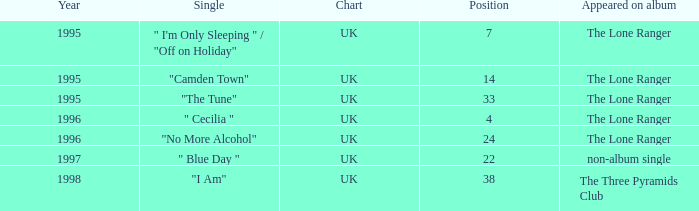What's the typical position after the year 1996? 30.0. Parse the table in full. {'header': ['Year', 'Single', 'Chart', 'Position', 'Appeared on album'], 'rows': [['1995', '" I\'m Only Sleeping " / "Off on Holiday"', 'UK', '7', 'The Lone Ranger'], ['1995', '"Camden Town"', 'UK', '14', 'The Lone Ranger'], ['1995', '"The Tune"', 'UK', '33', 'The Lone Ranger'], ['1996', '" Cecilia "', 'UK', '4', 'The Lone Ranger'], ['1996', '"No More Alcohol"', 'UK', '24', 'The Lone Ranger'], ['1997', '" Blue Day "', 'UK', '22', 'non-album single'], ['1998', '"I Am"', 'UK', '38', 'The Three Pyramids Club']]} 